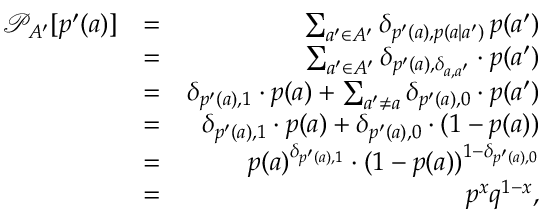Convert formula to latex. <formula><loc_0><loc_0><loc_500><loc_500>\begin{array} { r l r } { \mathcal { P } _ { A ^ { \prime } } [ p ^ { \prime } ( a ) ] } & { = } & { \sum _ { a ^ { \prime } \in A ^ { \prime } } \delta _ { p ^ { \prime } ( a ) , p ( a | a ^ { \prime } ) } \, p ( a ^ { \prime } ) } \\ & { = } & { \sum _ { a ^ { \prime } \in A ^ { \prime } } \delta _ { p ^ { \prime } ( a ) , \delta _ { a , a ^ { \prime } } } \cdot p ( a ^ { \prime } ) } \\ & { = } & { \delta _ { p ^ { \prime } ( a ) , 1 } \cdot p ( a ) + \sum _ { a ^ { \prime } \neq a } \delta _ { p ^ { \prime } ( a ) , 0 } \cdot p ( a ^ { \prime } ) } \\ & { = } & { \delta _ { p ^ { \prime } ( a ) , 1 } \cdot p ( a ) + \delta _ { p ^ { \prime } ( a ) , 0 } \cdot ( 1 - p ( a ) ) } \\ & { = } & { p ( a ) ^ { \delta _ { p ^ { \prime } ( a ) , 1 } } \cdot ( 1 - p ( a ) ) ^ { 1 - \delta _ { p ^ { \prime } ( a ) , 0 } } } \\ & { = } & { p ^ { x } q ^ { 1 - x } , } \end{array}</formula> 